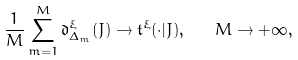<formula> <loc_0><loc_0><loc_500><loc_500>\frac { 1 } { M } \sum _ { m = 1 } ^ { M } \mathfrak { d } ^ { \xi } _ { \Delta _ { m } } ( J ) \rightarrow \mathfrak { t } ^ { \xi } ( \cdot | J ) , \quad M \rightarrow + \infty ,</formula> 